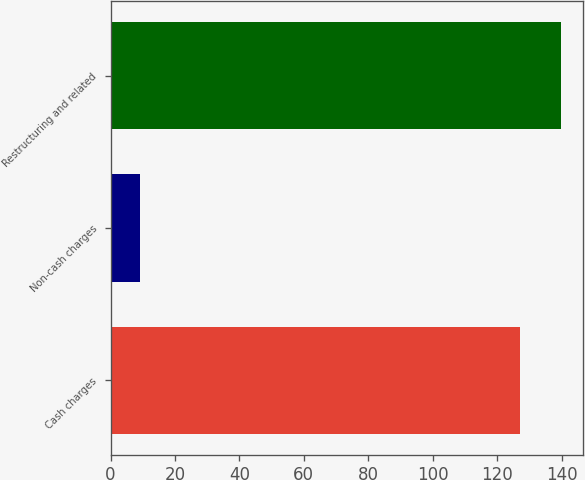<chart> <loc_0><loc_0><loc_500><loc_500><bar_chart><fcel>Cash charges<fcel>Non-cash charges<fcel>Restructuring and related<nl><fcel>127<fcel>9<fcel>139.7<nl></chart> 